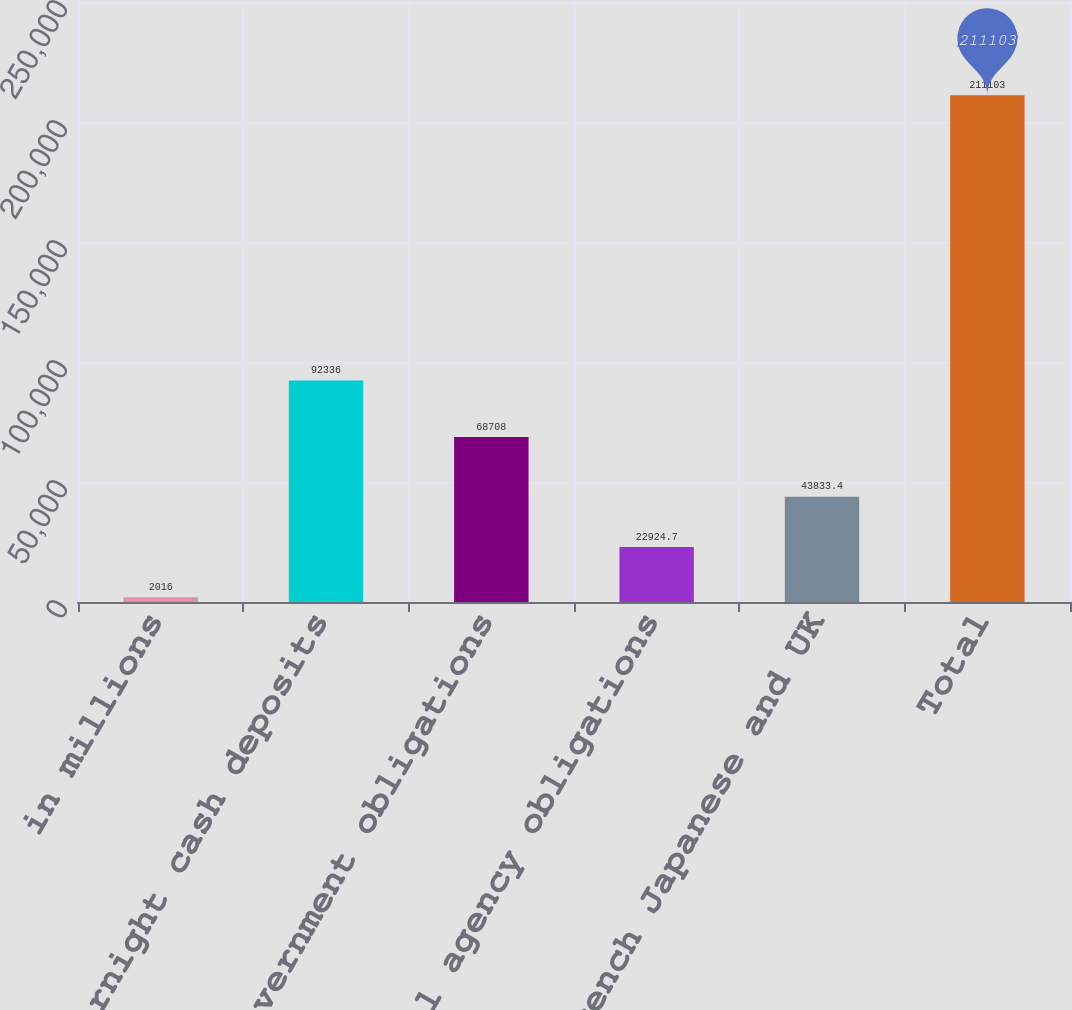Convert chart. <chart><loc_0><loc_0><loc_500><loc_500><bar_chart><fcel>in millions<fcel>Overnight cash deposits<fcel>US government obligations<fcel>US federal agency obligations<fcel>German French Japanese and UK<fcel>Total<nl><fcel>2016<fcel>92336<fcel>68708<fcel>22924.7<fcel>43833.4<fcel>211103<nl></chart> 